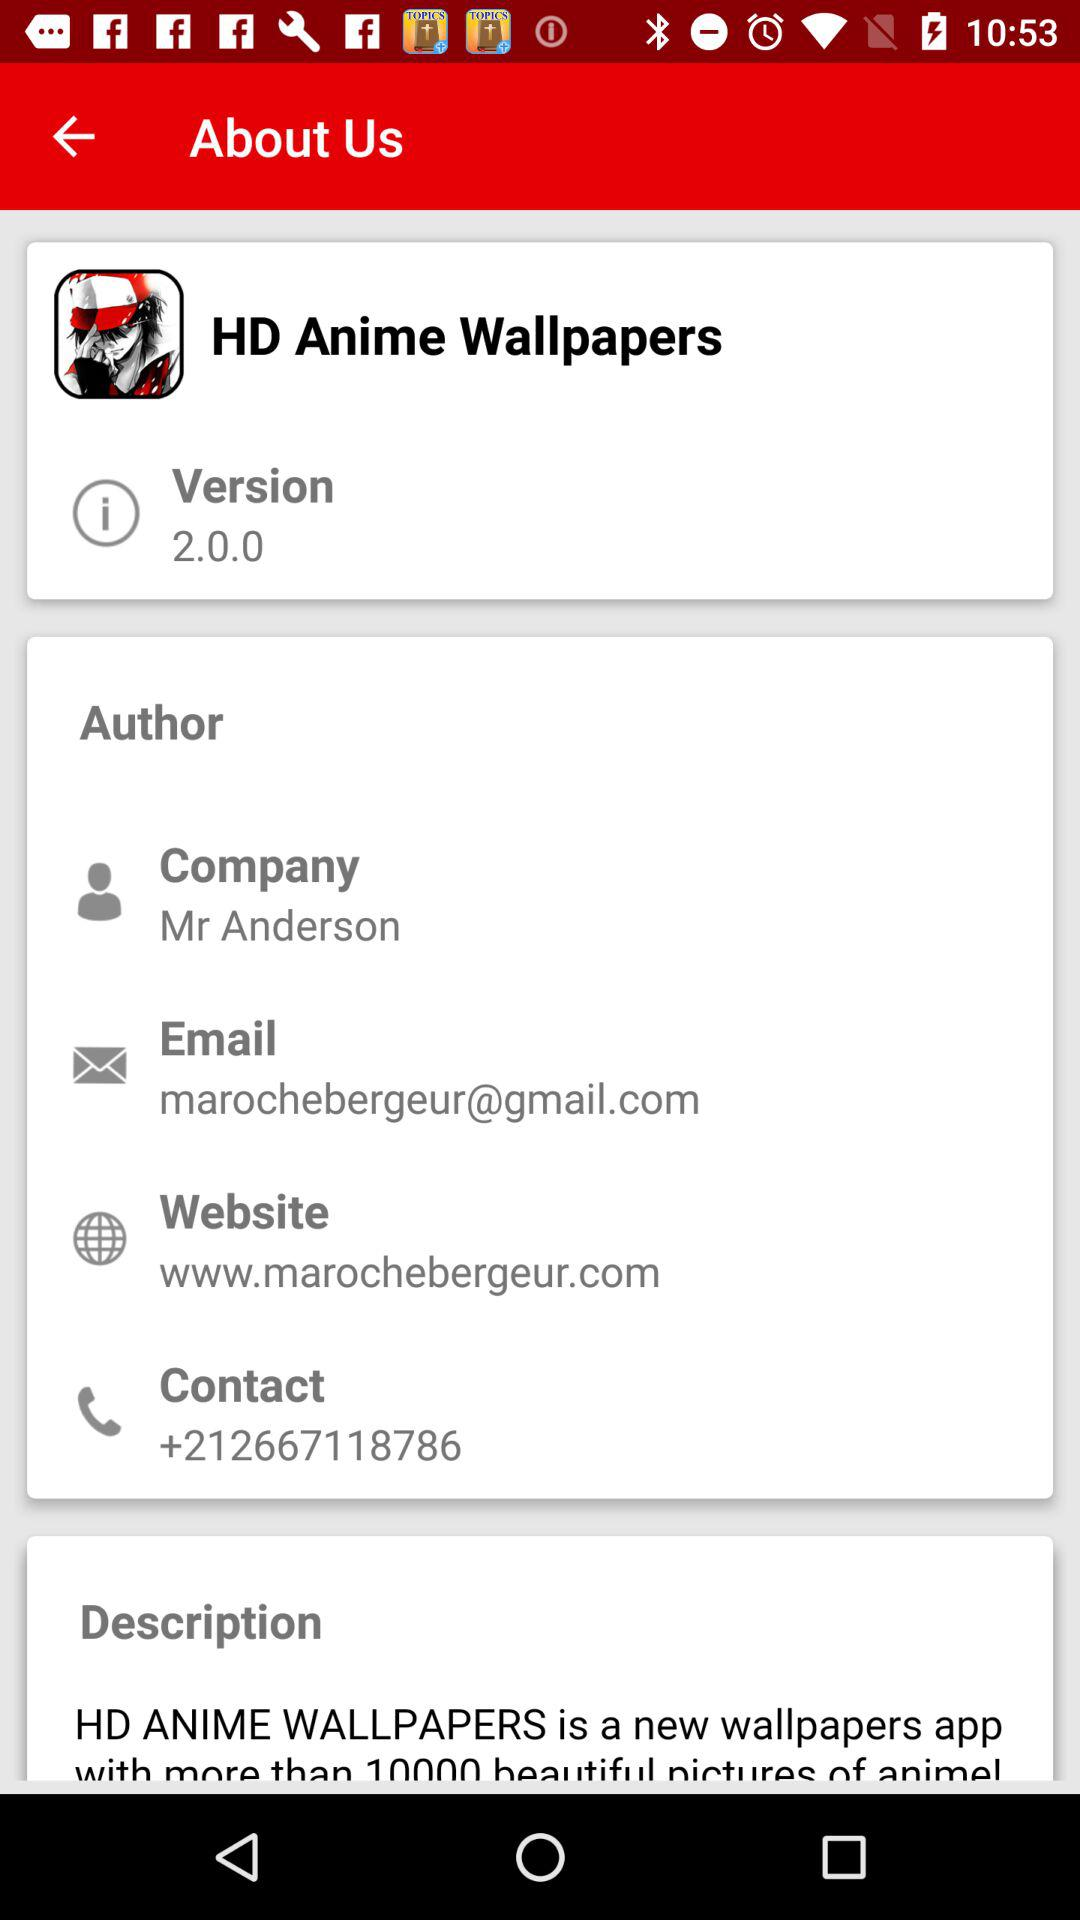What is the contact number? The contact number is +212667118786. 